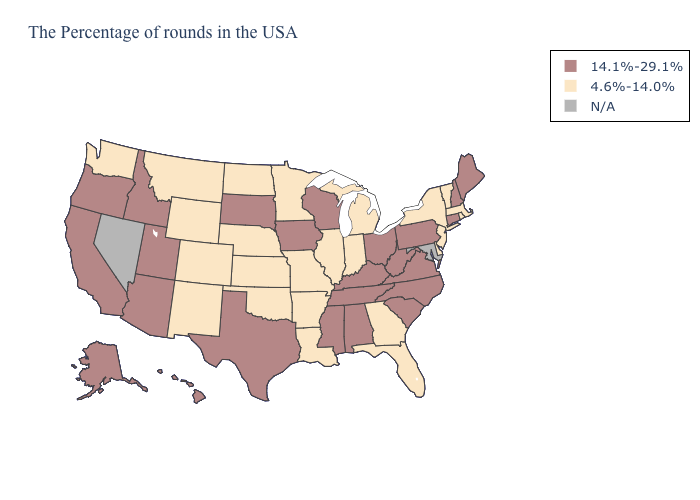Is the legend a continuous bar?
Keep it brief. No. What is the value of Maryland?
Give a very brief answer. N/A. What is the value of Nebraska?
Keep it brief. 4.6%-14.0%. What is the highest value in states that border Delaware?
Short answer required. 14.1%-29.1%. Does Connecticut have the highest value in the Northeast?
Concise answer only. Yes. What is the highest value in the South ?
Quick response, please. 14.1%-29.1%. Name the states that have a value in the range 4.6%-14.0%?
Be succinct. Massachusetts, Rhode Island, Vermont, New York, New Jersey, Delaware, Florida, Georgia, Michigan, Indiana, Illinois, Louisiana, Missouri, Arkansas, Minnesota, Kansas, Nebraska, Oklahoma, North Dakota, Wyoming, Colorado, New Mexico, Montana, Washington. Among the states that border Maryland , does Delaware have the lowest value?
Quick response, please. Yes. Name the states that have a value in the range 14.1%-29.1%?
Answer briefly. Maine, New Hampshire, Connecticut, Pennsylvania, Virginia, North Carolina, South Carolina, West Virginia, Ohio, Kentucky, Alabama, Tennessee, Wisconsin, Mississippi, Iowa, Texas, South Dakota, Utah, Arizona, Idaho, California, Oregon, Alaska, Hawaii. What is the lowest value in the USA?
Give a very brief answer. 4.6%-14.0%. Among the states that border Georgia , does North Carolina have the highest value?
Concise answer only. Yes. Name the states that have a value in the range N/A?
Write a very short answer. Maryland, Nevada. What is the lowest value in the USA?
Short answer required. 4.6%-14.0%. Name the states that have a value in the range 4.6%-14.0%?
Concise answer only. Massachusetts, Rhode Island, Vermont, New York, New Jersey, Delaware, Florida, Georgia, Michigan, Indiana, Illinois, Louisiana, Missouri, Arkansas, Minnesota, Kansas, Nebraska, Oklahoma, North Dakota, Wyoming, Colorado, New Mexico, Montana, Washington. 